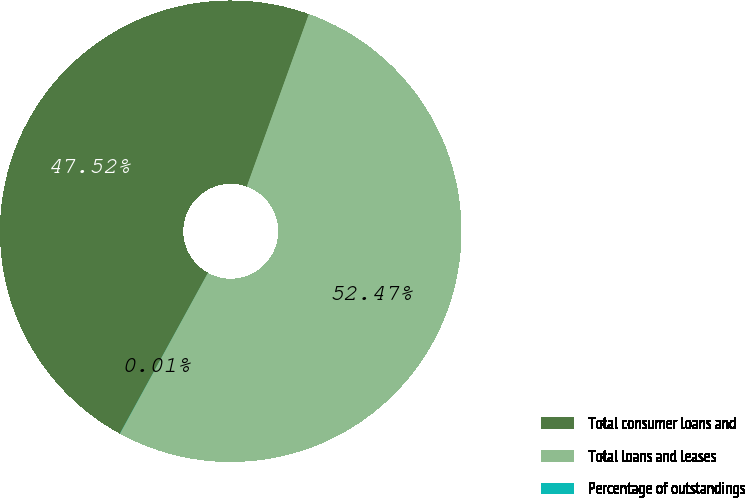Convert chart to OTSL. <chart><loc_0><loc_0><loc_500><loc_500><pie_chart><fcel>Total consumer loans and<fcel>Total loans and leases<fcel>Percentage of outstandings<nl><fcel>47.52%<fcel>52.47%<fcel>0.01%<nl></chart> 